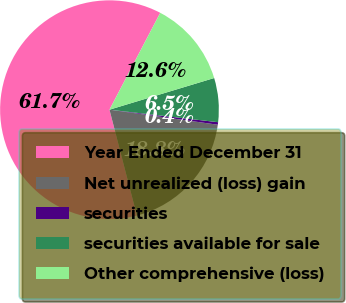Convert chart to OTSL. <chart><loc_0><loc_0><loc_500><loc_500><pie_chart><fcel>Year Ended December 31<fcel>Net unrealized (loss) gain<fcel>securities<fcel>securities available for sale<fcel>Other comprehensive (loss)<nl><fcel>61.72%<fcel>18.77%<fcel>0.37%<fcel>6.5%<fcel>12.64%<nl></chart> 